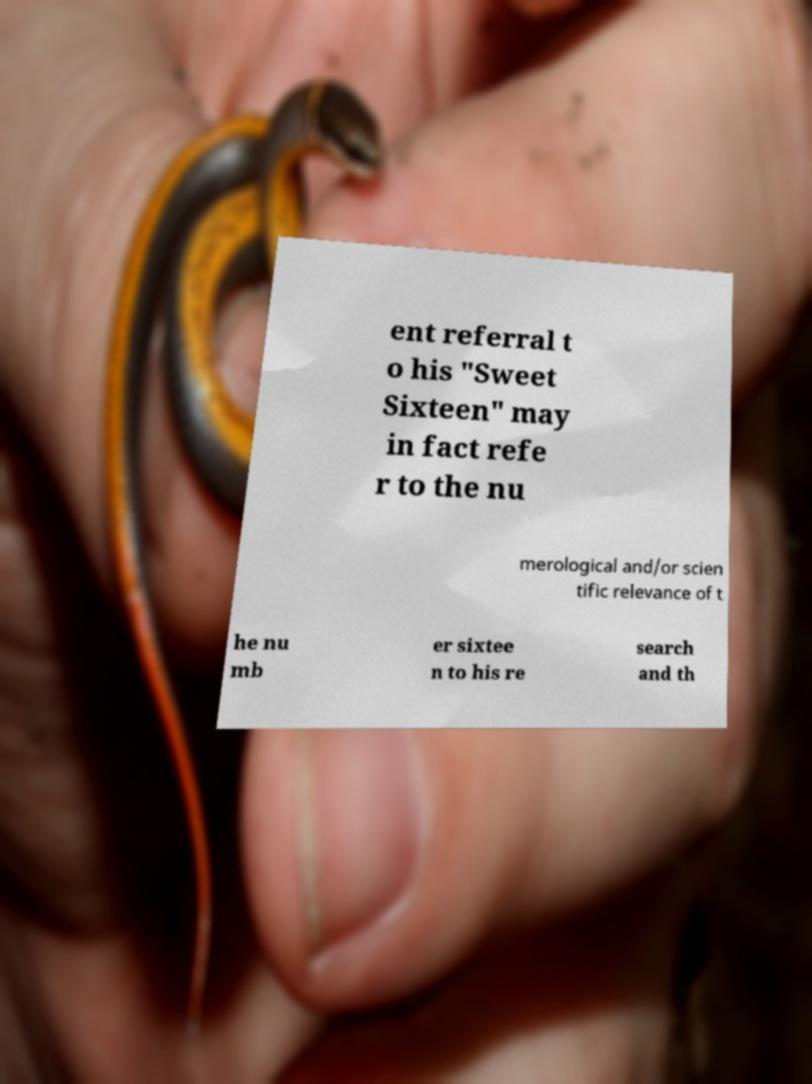What messages or text are displayed in this image? I need them in a readable, typed format. ent referral t o his "Sweet Sixteen" may in fact refe r to the nu merological and/or scien tific relevance of t he nu mb er sixtee n to his re search and th 